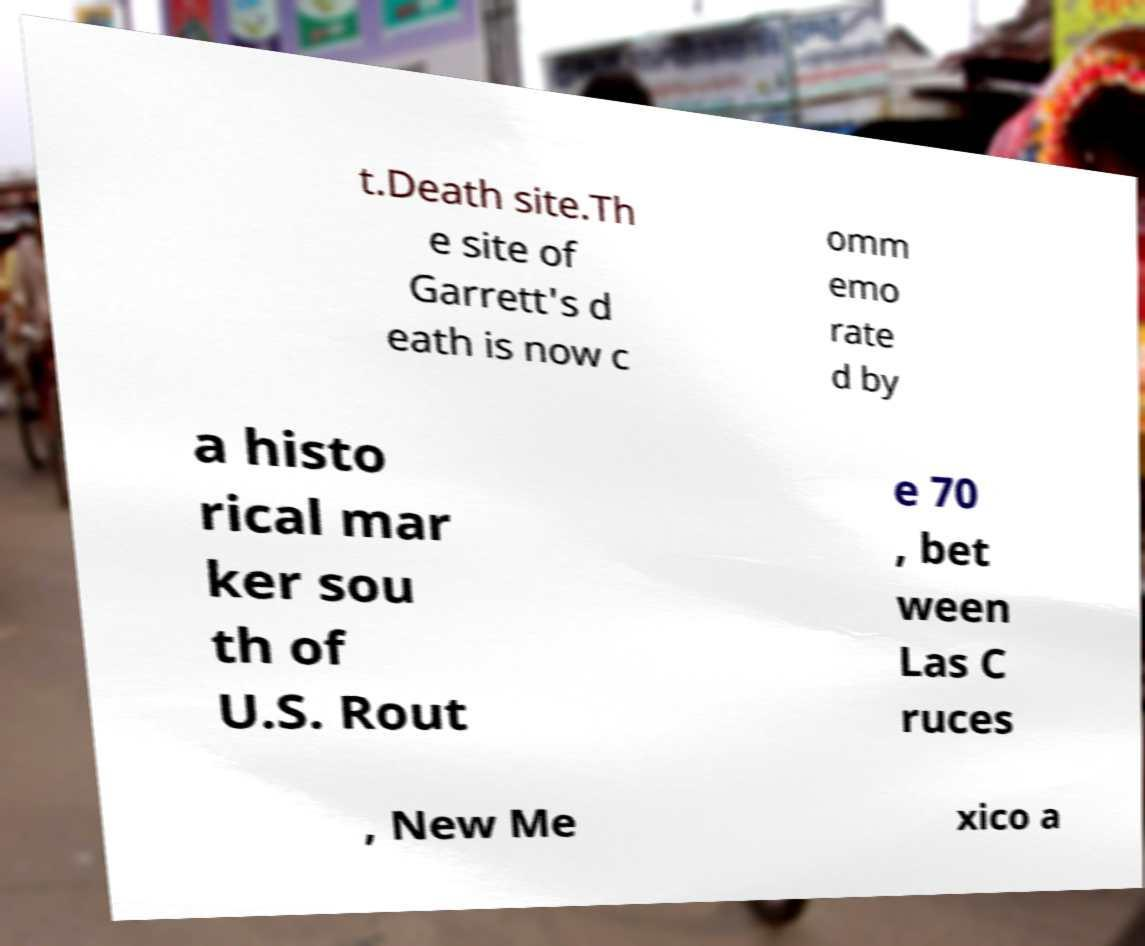What messages or text are displayed in this image? I need them in a readable, typed format. t.Death site.Th e site of Garrett's d eath is now c omm emo rate d by a histo rical mar ker sou th of U.S. Rout e 70 , bet ween Las C ruces , New Me xico a 